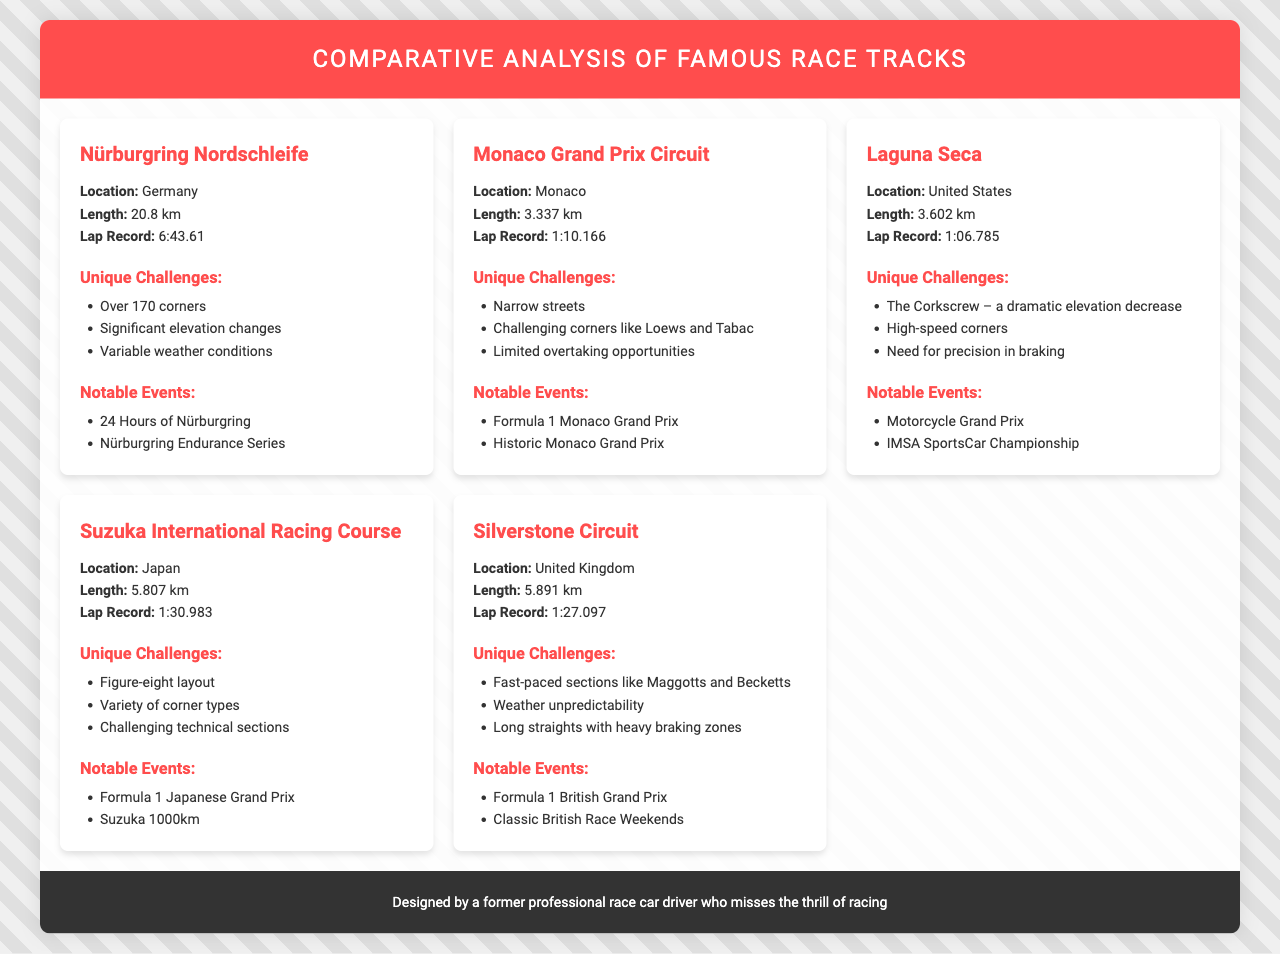What is the lap record for Nürburgring Nordschleife? The lap record is specifically mentioned under the Nürburgring Nordschleife section as 6:43.61.
Answer: 6:43.61 Which race track has a length of 3.602 km? The document provides the length of Laguna Seca as 3.602 km.
Answer: Laguna Seca What unique challenge is associated with the Monaco Grand Prix Circuit? The document lists "Narrow streets" as one of the unique challenges for this track.
Answer: Narrow streets What is the location of Silverstone Circuit? The location of Silverstone Circuit is mentioned as the United Kingdom in the document.
Answer: United Kingdom Which race track features The Corkscrew? The unique challenge "The Corkscrew" is highlighted in the Laguna Seca section of the document.
Answer: Laguna Seca What notable event is held at Suzuka International Racing Course? The document indicates the "Formula 1 Japanese Grand Prix" as a notable event for this track.
Answer: Formula 1 Japanese Grand Prix How many corners does the Nürburgring Nordschleife have? The document states that there are "Over 170 corners" on the Nürburgring Nordschleife.
Answer: Over 170 corners What is the lap record for Silverstone Circuit? The document specifically mentions the lap record as 1:27.097 for Silverstone Circuit.
Answer: 1:27.097 Which track has a variety of corner types as a unique challenge? The Suzuka International Racing Course is mentioned to have a "Variety of corner types" as a unique challenge.
Answer: Suzuka International Racing Course 